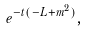<formula> <loc_0><loc_0><loc_500><loc_500>e ^ { - t ( - L + m ^ { 2 } ) } ,</formula> 